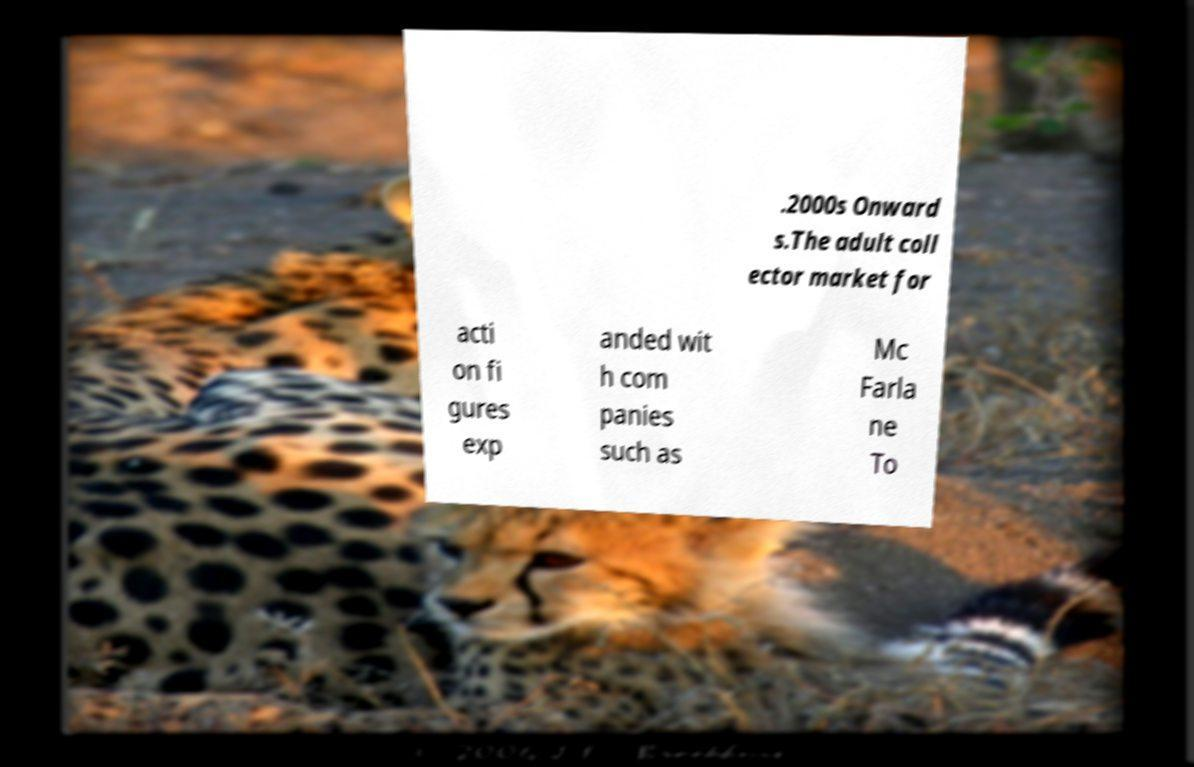For documentation purposes, I need the text within this image transcribed. Could you provide that? .2000s Onward s.The adult coll ector market for acti on fi gures exp anded wit h com panies such as Mc Farla ne To 